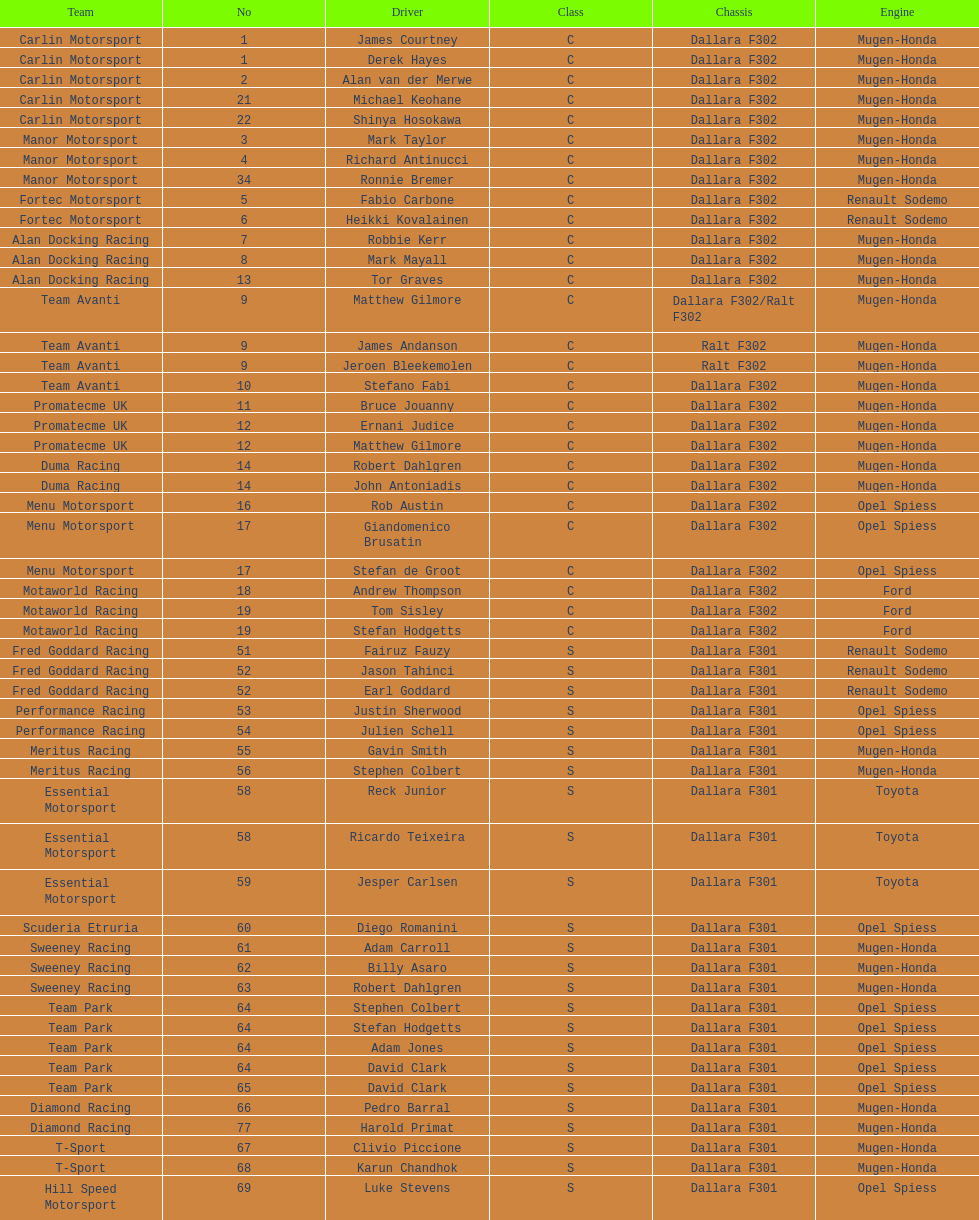Who had more drivers, team avanti or motaworld racing? Team Avanti. 